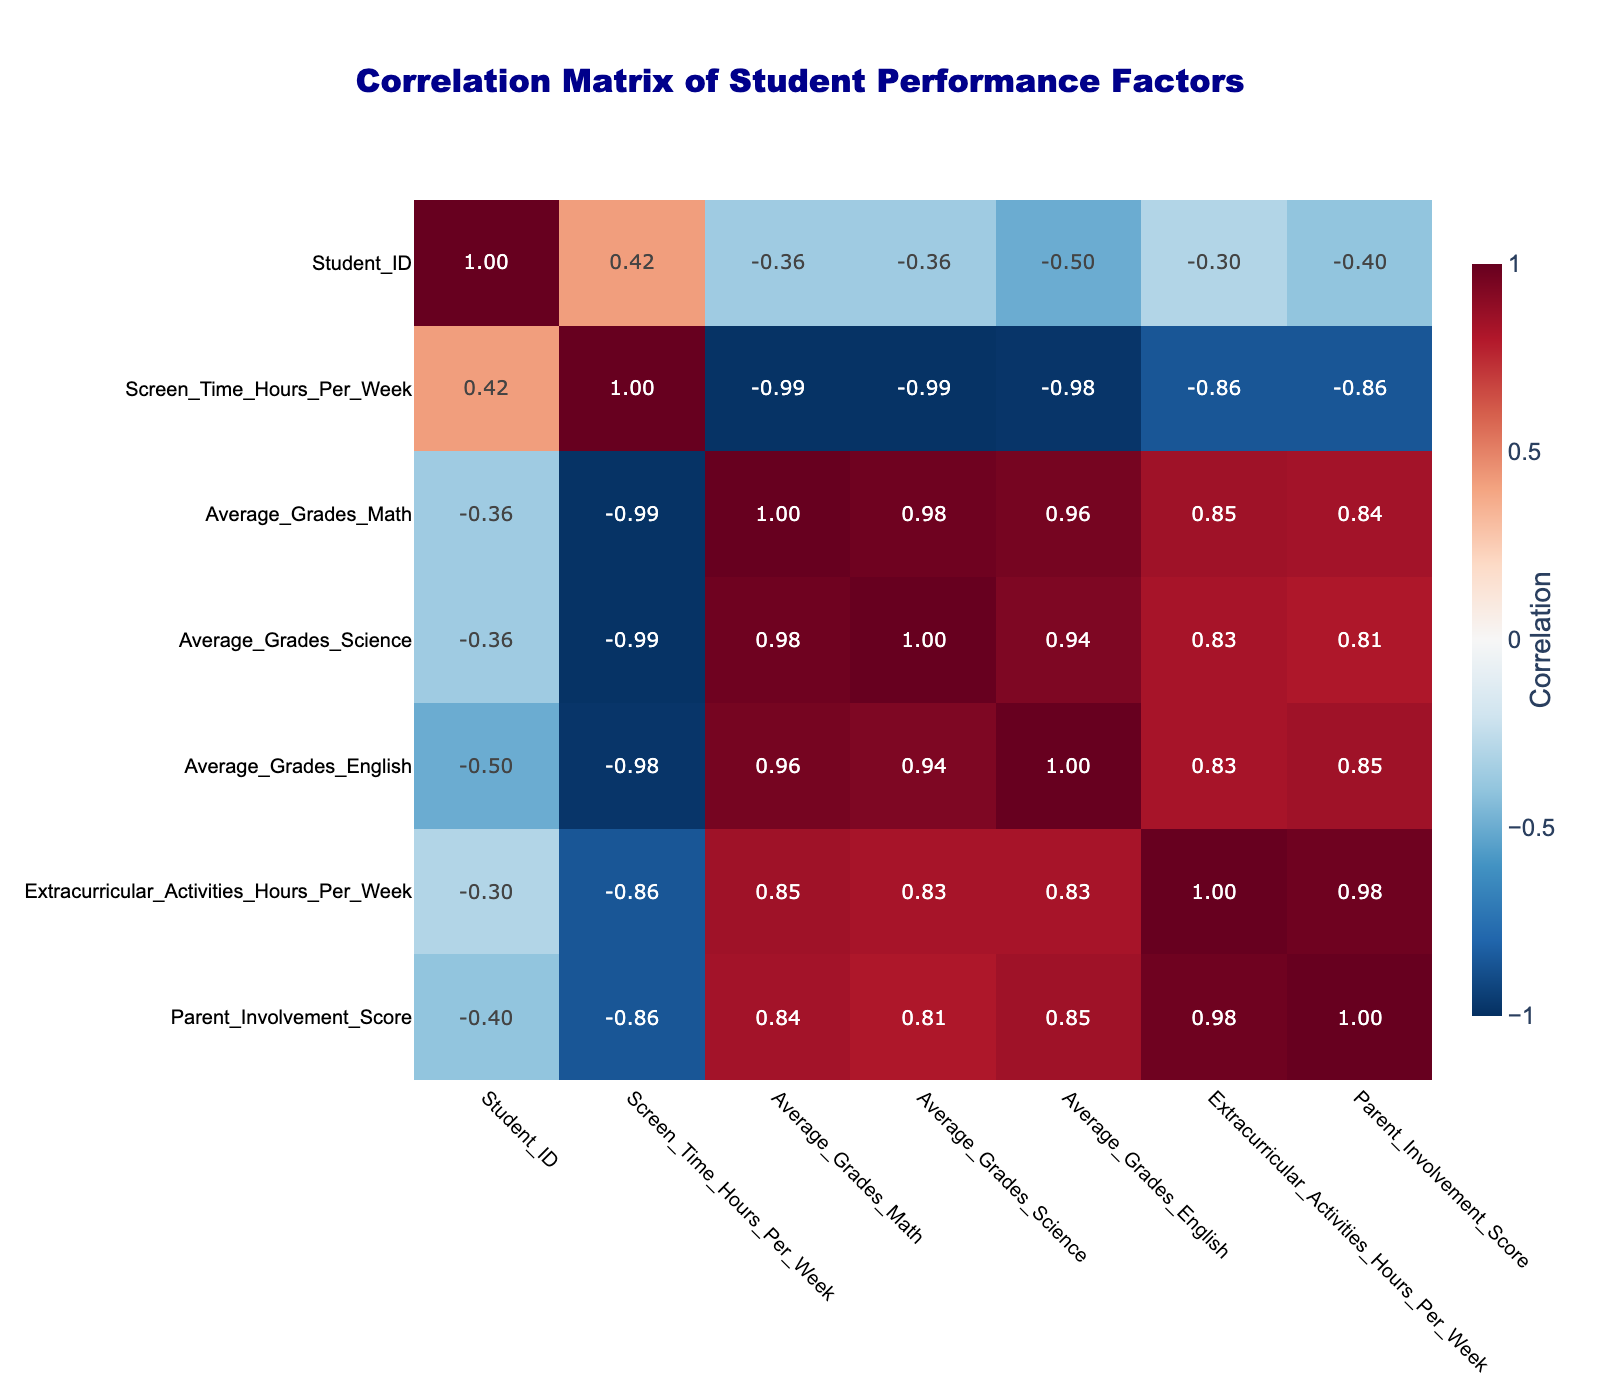What is the correlation between screen time hours per week and average grades in Math? To find the correlation, we look at the values in the correlation table. The correlation between Screen_Time_Hours_Per_Week and Average_Grades_Math is -0.85. This indicates a strong negative correlation, meaning as screen time increases, average math grades tend to decrease.
Answer: -0.85 Is there a positive correlation between parent involvement score and average grades in English? Referring to the table, the correlation between Parent_Involvement_Score and Average_Grades_English is 0.85. This indicates a strong positive correlation, meaning higher parent involvement is associated with better average grades in English.
Answer: Yes What is the average screen time hours per week for students with average grades in Science above 80? We identify the students with Science grades above 80: Students 1, 4, 5, and 8 have Science grades of 80, 85, 87, and 79, respectively. The screen times for these students are 10, 5, 8, and 12 hours per week. Adding these (10 + 5 + 8 + 12 = 35) and dividing by 4 gives us an average of 8.75 hours per week.
Answer: 8.75 Which student has the highest average grades in Math and what is their screen time? By checking the Math grades, Student 4 has the highest average grade of 90. The screen time for Student 4 is 5 hours per week.
Answer: Student 4, 5 hours Is the average grades in Science lower for students who spend more than 20 hours on screen time per week compared to those who spend less? First, identify students with screen time over 20 hours: Students 6 (65) and 7 (58) have average grades in Science of 65 and 58, respectively. The average for these students is (65 + 58) / 2 = 61.5. Now, for students below 20 hours (Students 1 through 5, and 8): their Science grades are 80, 85, 87, 79, and 73. The average for these grades is (80 + 85 + 87 + 79 + 73) / 5 = 80.4. Comparing the two averages (61.5 vs 80.4), we see that the average for higher screen time is indeed lower.
Answer: Yes What is the correlation between extracurricular activities hours per week and average grades in Science? By referring to the correlation table, the correlation between Extracurricular_Activities_Hours_Per_Week and Average_Grades_Science is 0.73. This shows a moderate positive correlation, suggesting that more hours spent on extracurricular activities are related to higher average grades in Science.
Answer: 0.73 